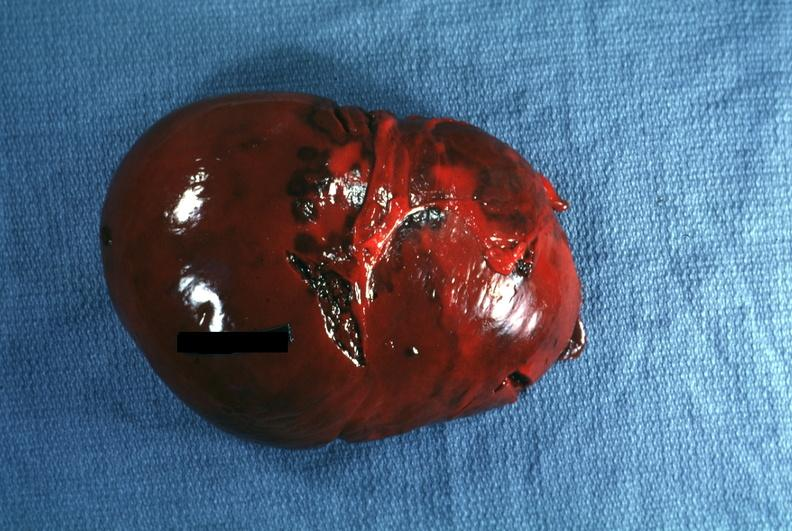s spleen present?
Answer the question using a single word or phrase. Yes 